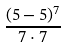<formula> <loc_0><loc_0><loc_500><loc_500>\frac { ( 5 - 5 ) ^ { 7 } } { 7 \cdot 7 }</formula> 